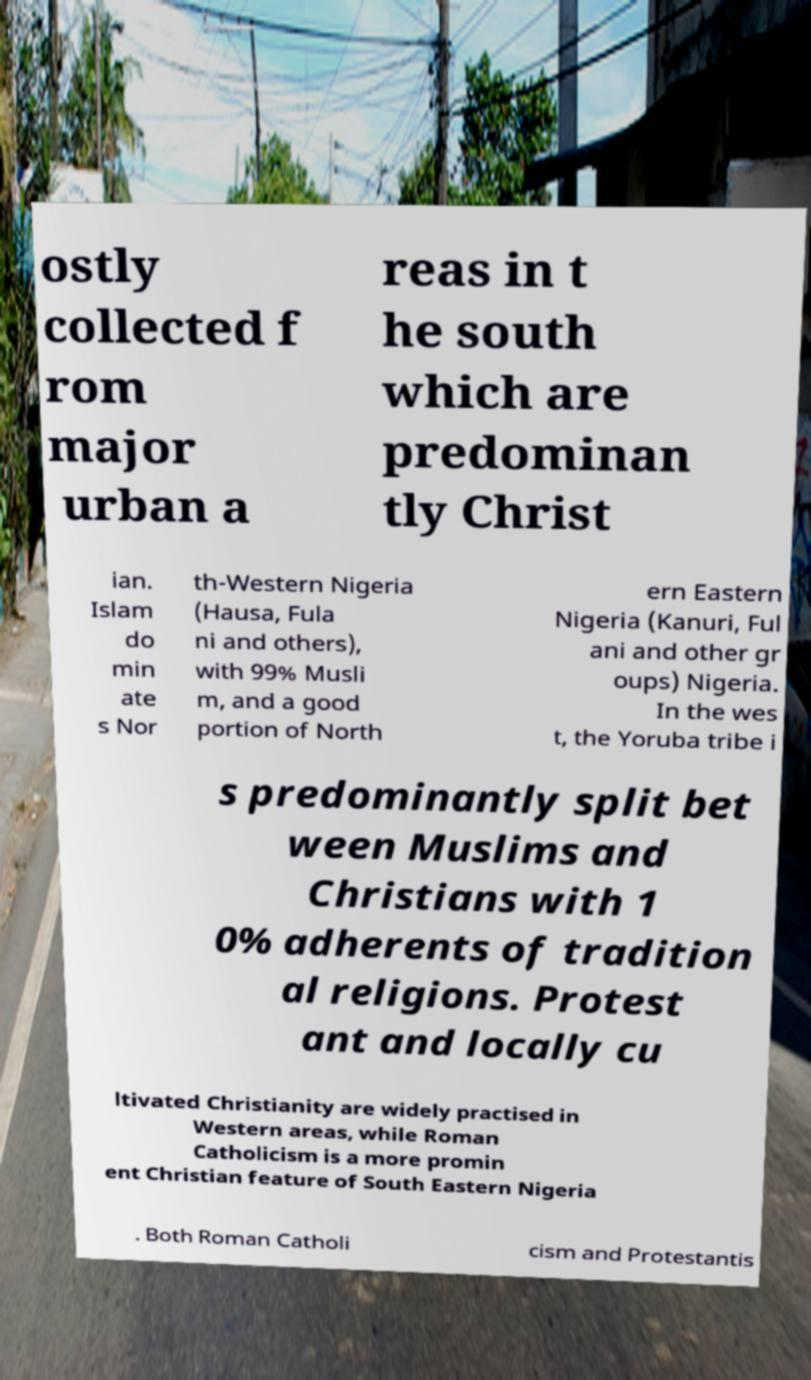Please identify and transcribe the text found in this image. ostly collected f rom major urban a reas in t he south which are predominan tly Christ ian. Islam do min ate s Nor th-Western Nigeria (Hausa, Fula ni and others), with 99% Musli m, and a good portion of North ern Eastern Nigeria (Kanuri, Ful ani and other gr oups) Nigeria. In the wes t, the Yoruba tribe i s predominantly split bet ween Muslims and Christians with 1 0% adherents of tradition al religions. Protest ant and locally cu ltivated Christianity are widely practised in Western areas, while Roman Catholicism is a more promin ent Christian feature of South Eastern Nigeria . Both Roman Catholi cism and Protestantis 